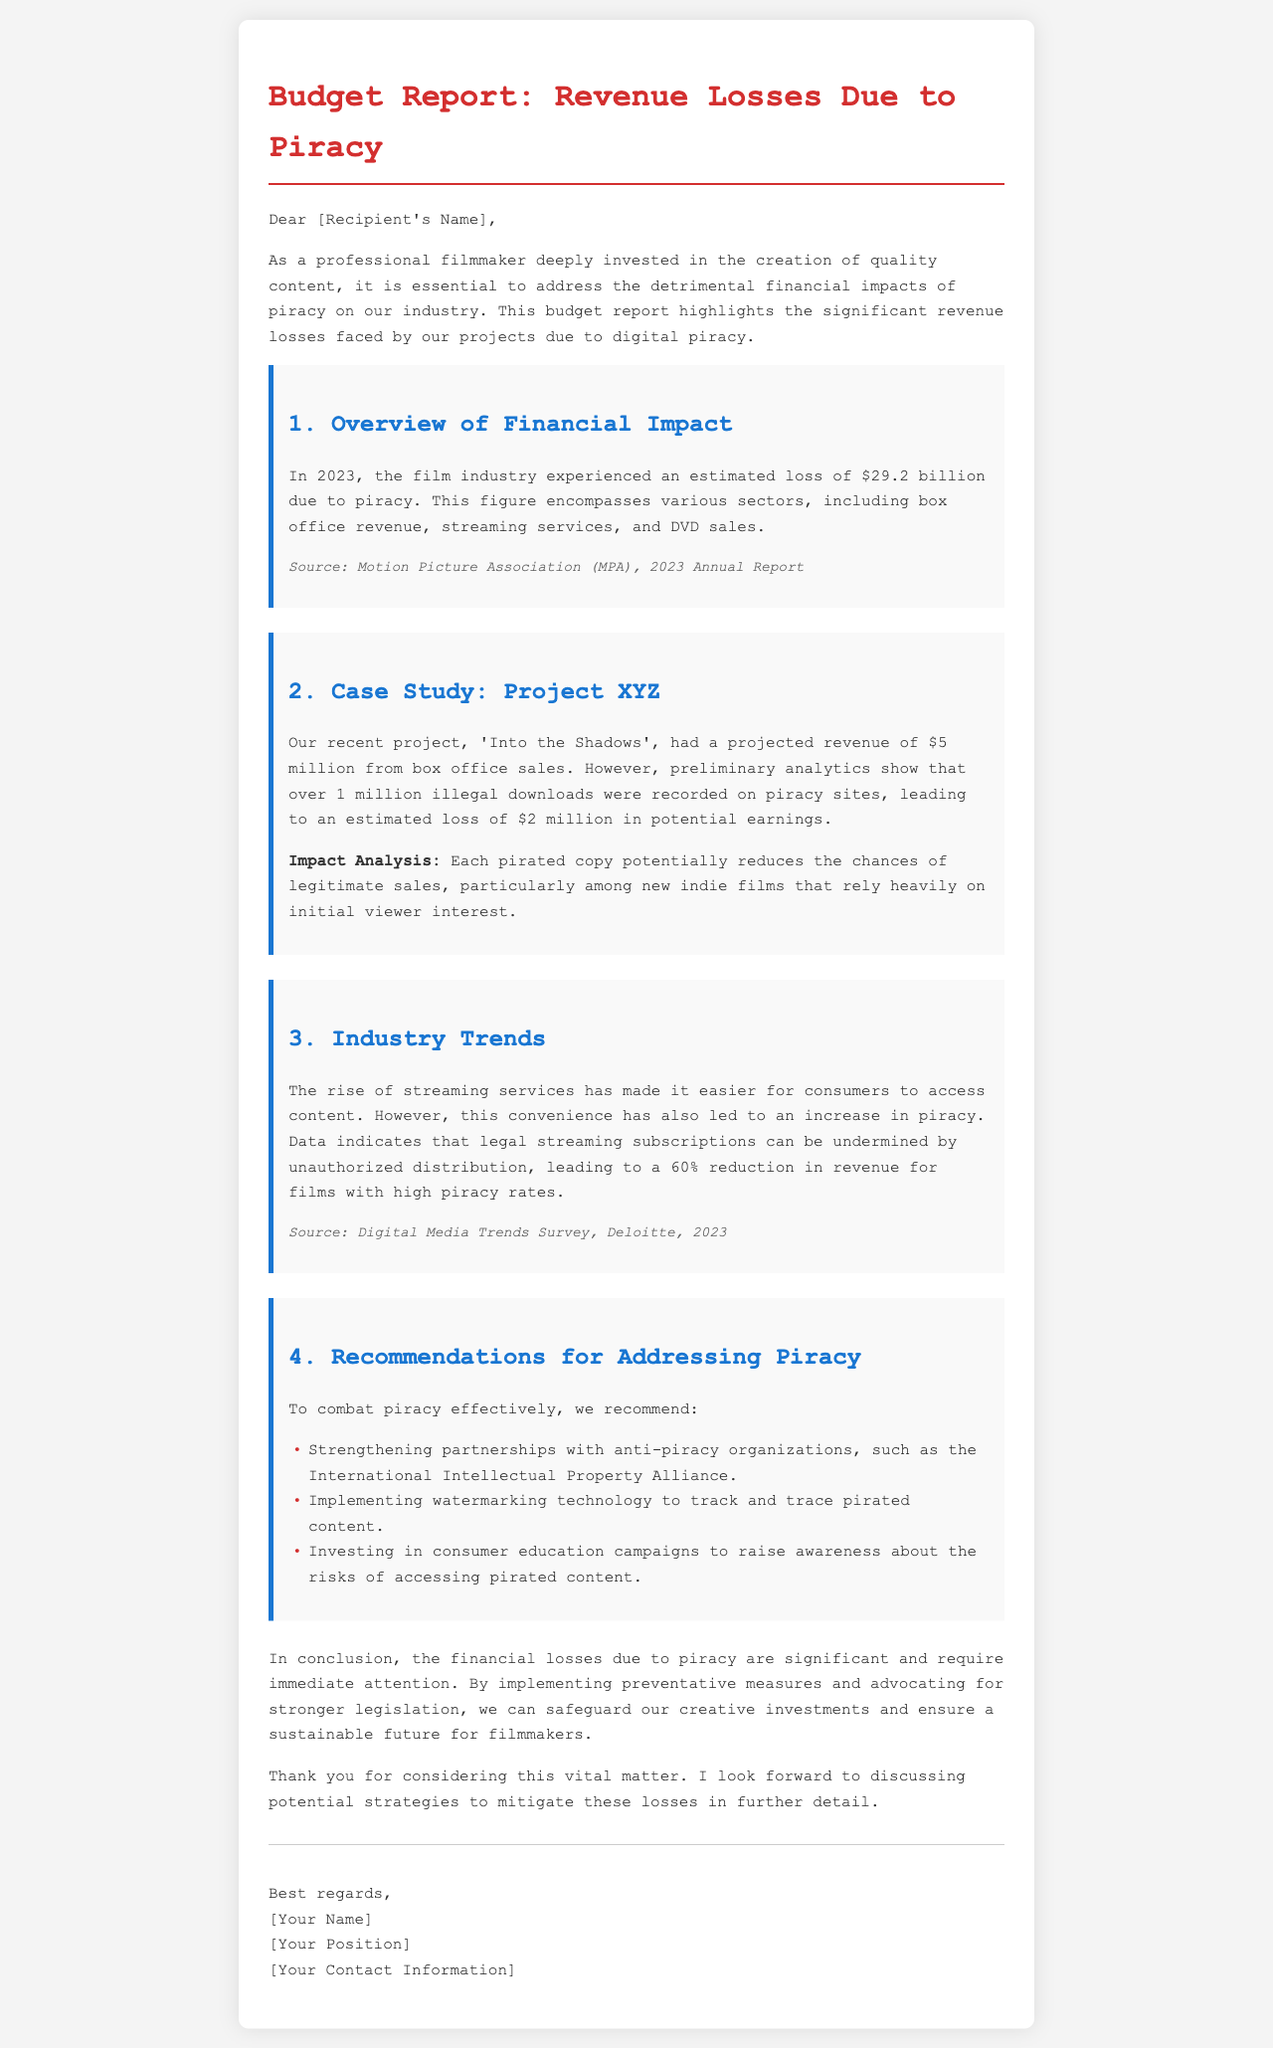What was the estimated revenue loss due to piracy in 2023? The document states that the film industry experienced an estimated loss of $29.2 billion due to piracy in 2023.
Answer: $29.2 billion What was the projected revenue for the film 'Into the Shadows'? The projected revenue for the film 'Into the Shadows' was $5 million.
Answer: $5 million How many illegal downloads were recorded for 'Into the Shadows'? It mentions that over 1 million illegal downloads were recorded for 'Into the Shadows'.
Answer: 1 million What percentage reduction in revenue is indicated for films with high piracy rates? The document indicates a 60% reduction in revenue for films with high piracy rates.
Answer: 60% Which organization is recommended for partnership to combat piracy? The document suggests strengthening partnerships with the International Intellectual Property Alliance.
Answer: International Intellectual Property Alliance What is one of the recommendations for addressing piracy? One recommendation is to implement watermarking technology to track and trace pirated content.
Answer: Implementing watermarking technology What is the source of the data regarding the film industry's revenue loss? The source of the data regarding the film industry's revenue loss is the Motion Picture Association (MPA), 2023 Annual Report.
Answer: Motion Picture Association (MPA), 2023 Annual Report What is the purpose of the document? The purpose of the document is to highlight the significant revenue losses faced by projects due to digital piracy.
Answer: To highlight revenue losses due to digital piracy 